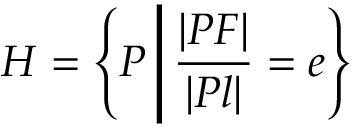<formula> <loc_0><loc_0><loc_500><loc_500>H = \left \{ P \, { \Big | } \, { \frac { | P F | } { | P l | } } = e \right \}</formula> 